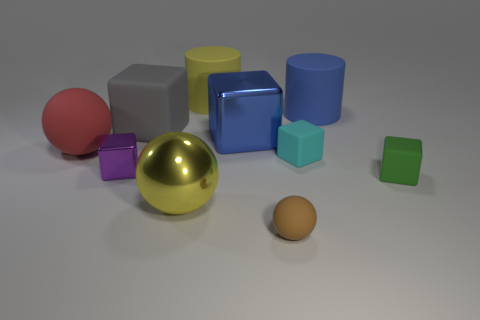Subtract all purple blocks. How many blocks are left? 4 Subtract all purple metallic blocks. How many blocks are left? 4 Subtract all red cubes. Subtract all brown balls. How many cubes are left? 5 Subtract all balls. How many objects are left? 7 Add 6 gray matte cubes. How many gray matte cubes are left? 7 Add 8 yellow metallic objects. How many yellow metallic objects exist? 9 Subtract 1 purple cubes. How many objects are left? 9 Subtract all blue matte cylinders. Subtract all small brown spheres. How many objects are left? 8 